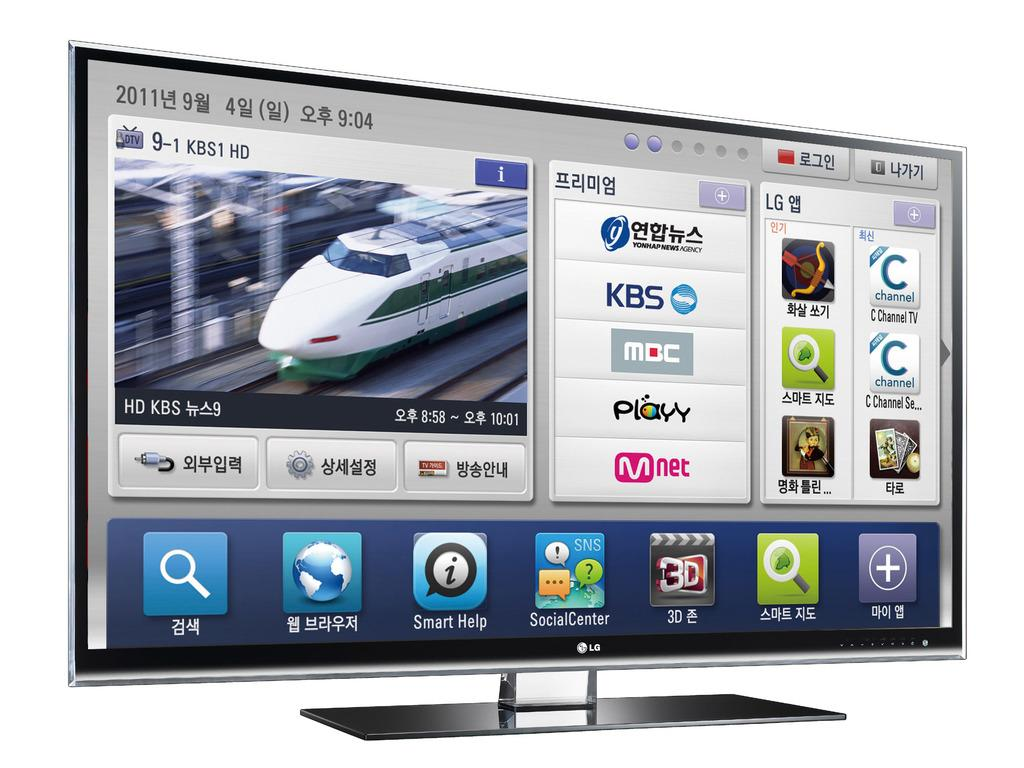<image>
Relay a brief, clear account of the picture shown. A computer monitor says the year 2011 in the upper left corner. 